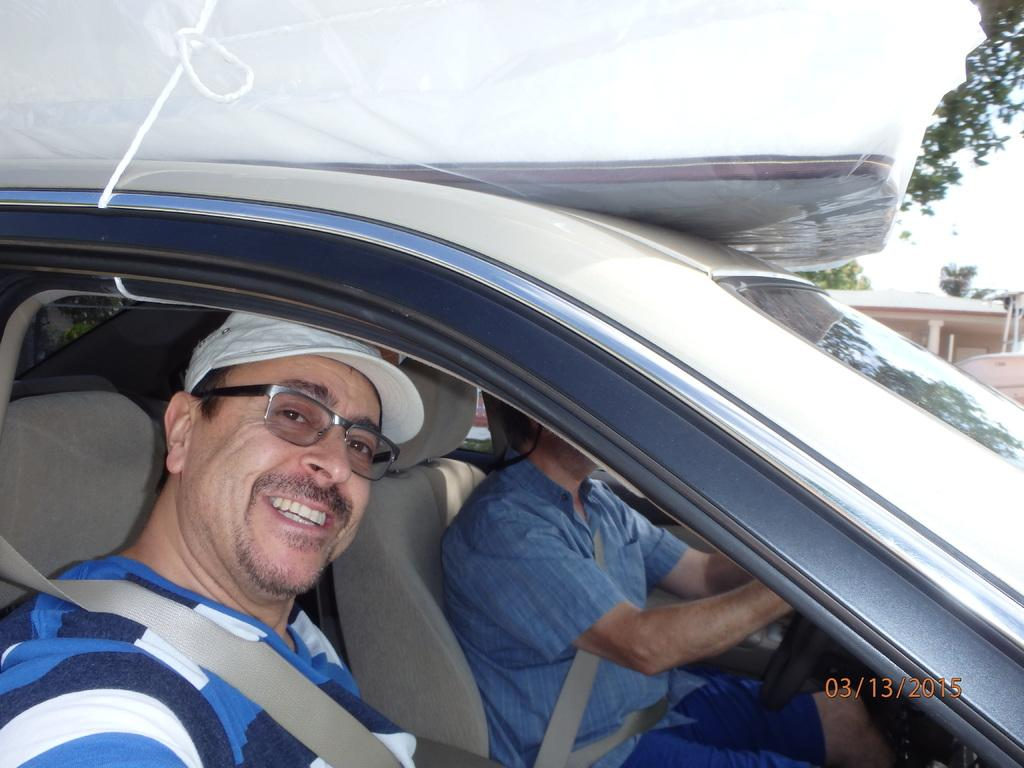What is happening inside the car in the image? There are two people sitting in a car. Can you describe the appearance of the person in the front? The guy in the front is wearing a cap. What is the emotional state of the person in the front? The guy in the front is laughing. What can be seen in the background of the image? There are trees visible at the top right side of the car. What types of toys are the dogs playing with in the image? There are no toys or dogs present in the image; it features two people sitting in a car. 